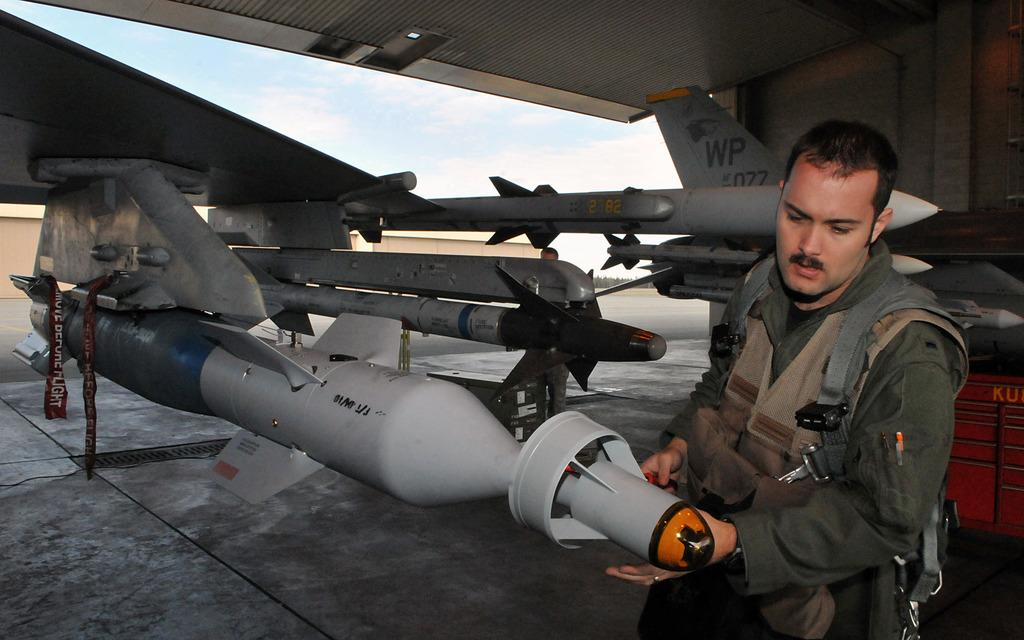<image>
Offer a succinct explanation of the picture presented. A man inspects a missle with the identifier WP on a wing in the background. 